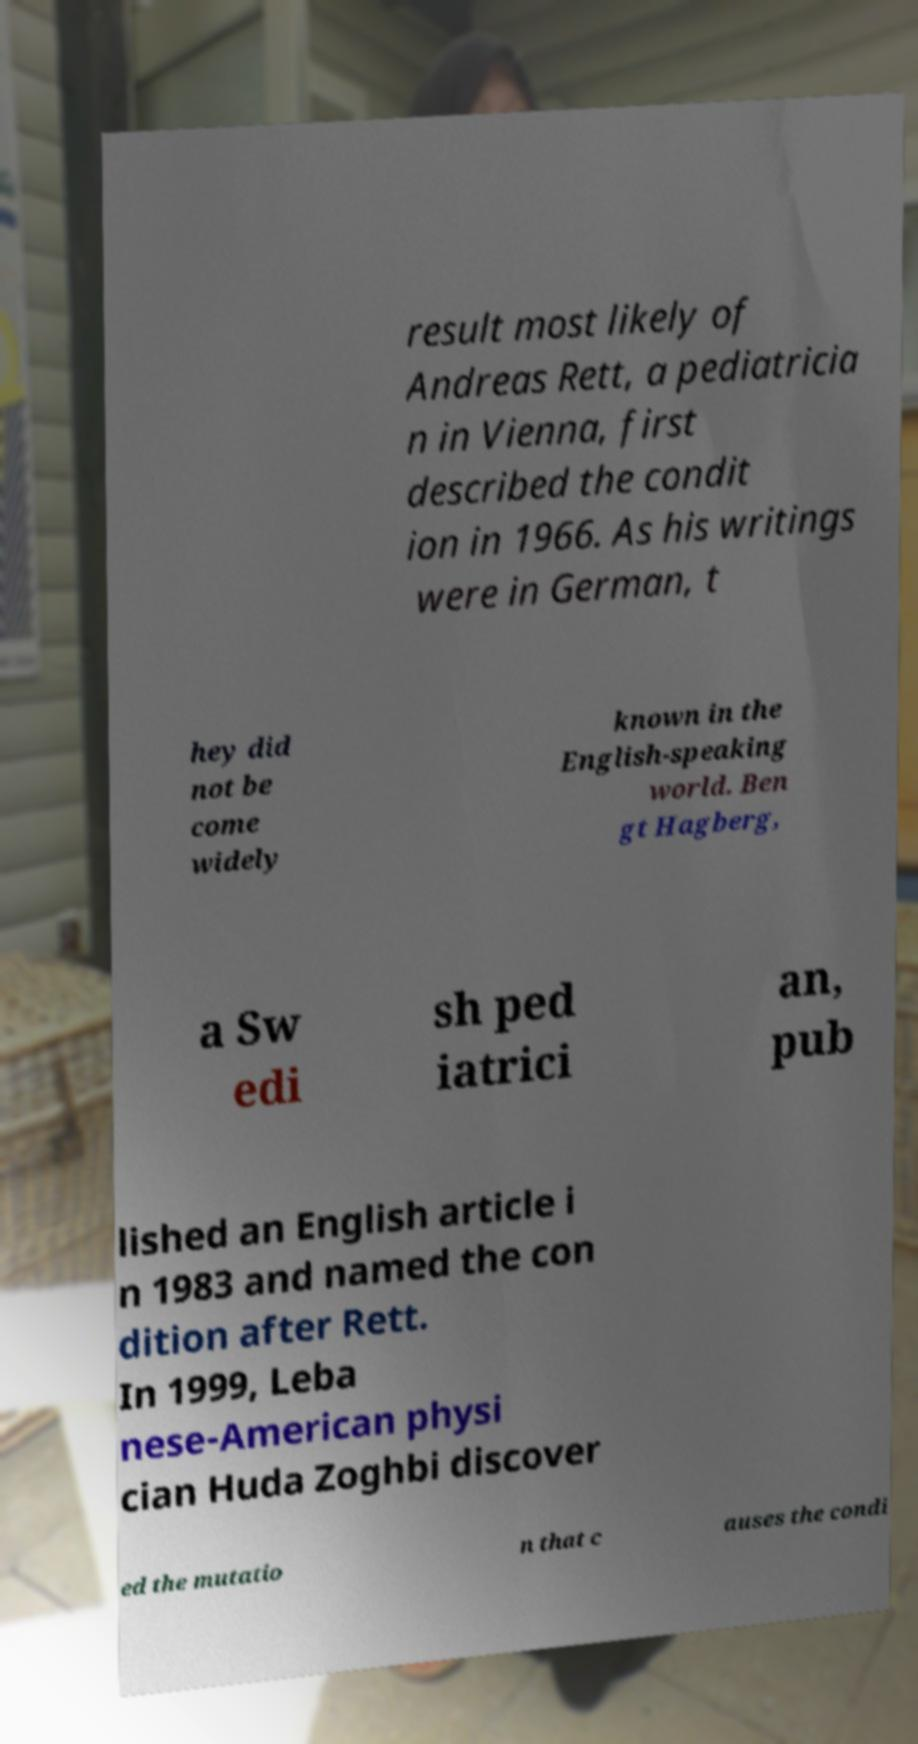What messages or text are displayed in this image? I need them in a readable, typed format. result most likely of Andreas Rett, a pediatricia n in Vienna, first described the condit ion in 1966. As his writings were in German, t hey did not be come widely known in the English-speaking world. Ben gt Hagberg, a Sw edi sh ped iatrici an, pub lished an English article i n 1983 and named the con dition after Rett. In 1999, Leba nese-American physi cian Huda Zoghbi discover ed the mutatio n that c auses the condi 